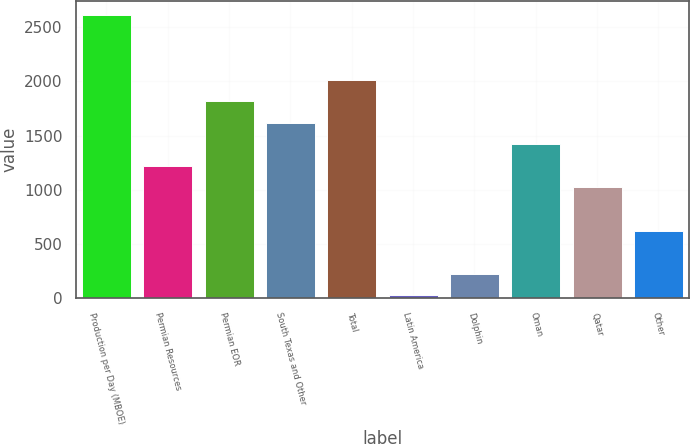<chart> <loc_0><loc_0><loc_500><loc_500><bar_chart><fcel>Production per Day (MBOE)<fcel>Permian Resources<fcel>Permian EOR<fcel>South Texas and Other<fcel>Total<fcel>Latin America<fcel>Dolphin<fcel>Oman<fcel>Qatar<fcel>Other<nl><fcel>2609.5<fcel>1220<fcel>1815.5<fcel>1617<fcel>2014<fcel>29<fcel>227.5<fcel>1418.5<fcel>1021.5<fcel>624.5<nl></chart> 